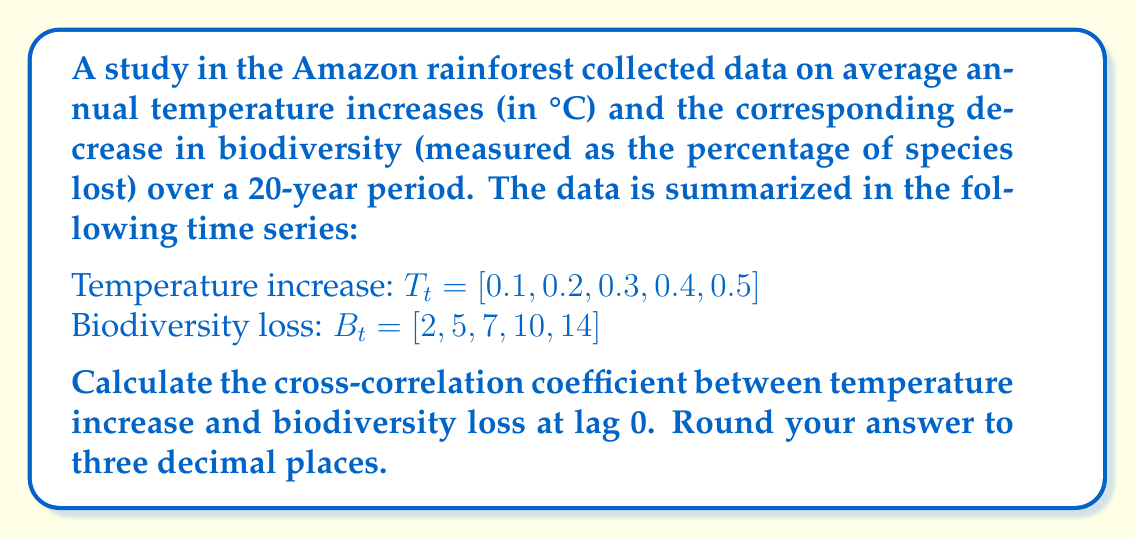Teach me how to tackle this problem. To calculate the cross-correlation coefficient at lag 0, we'll use the following steps:

1. Calculate the means of both time series:
   $\bar{T} = \frac{0.1 + 0.2 + 0.3 + 0.4 + 0.5}{5} = 0.3$
   $\bar{B} = \frac{2 + 5 + 7 + 10 + 14}{5} = 7.6$

2. Calculate the deviations from the mean for both series:
   $T_t - \bar{T} = [-0.2, -0.1, 0, 0.1, 0.2]$
   $B_t - \bar{B} = [-5.6, -2.6, -0.6, 2.4, 6.4]$

3. Multiply the deviations:
   $(-0.2)(-5.6) = 1.12$
   $(-0.1)(-2.6) = 0.26$
   $(0)(-0.6) = 0$
   $(0.1)(2.4) = 0.24$
   $(0.2)(6.4) = 1.28$

4. Sum the products:
   $\sum_{t=1}^{5} (T_t - \bar{T})(B_t - \bar{B}) = 1.12 + 0.26 + 0 + 0.24 + 1.28 = 2.9$

5. Calculate the standard deviations:
   $s_T = \sqrt{\frac{\sum_{t=1}^{5} (T_t - \bar{T})^2}{5}} = \sqrt{\frac{0.1}{5}} = 0.1414$
   $s_B = \sqrt{\frac{\sum_{t=1}^{5} (B_t - \bar{B})^2}{5}} = \sqrt{\frac{126}{5}} = 5.0199$

6. Apply the cross-correlation formula:
   $$r_{TB}(0) = \frac{\sum_{t=1}^{5} (T_t - \bar{T})(B_t - \bar{B})}{5s_T s_B}$$

   $$r_{TB}(0) = \frac{2.9}{5(0.1414)(5.0199)} = \frac{2.9}{3.5511} = 0.8166$$

7. Round to three decimal places: 0.817
Answer: 0.817 